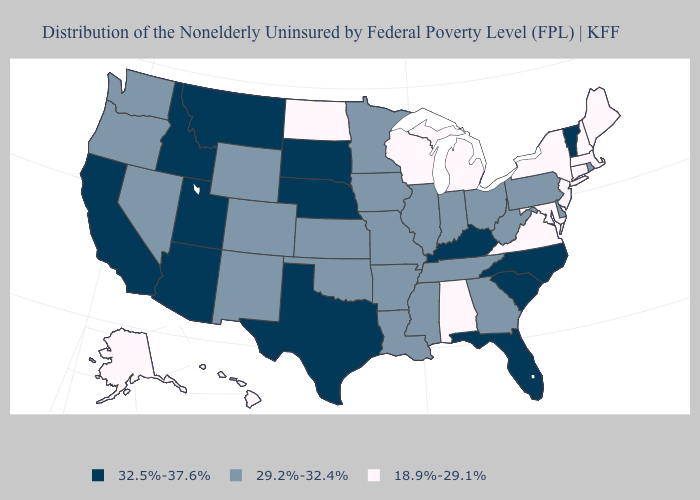Name the states that have a value in the range 32.5%-37.6%?
Be succinct. Arizona, California, Florida, Idaho, Kentucky, Montana, Nebraska, North Carolina, South Carolina, South Dakota, Texas, Utah, Vermont. Name the states that have a value in the range 32.5%-37.6%?
Short answer required. Arizona, California, Florida, Idaho, Kentucky, Montana, Nebraska, North Carolina, South Carolina, South Dakota, Texas, Utah, Vermont. Name the states that have a value in the range 29.2%-32.4%?
Short answer required. Arkansas, Colorado, Delaware, Georgia, Illinois, Indiana, Iowa, Kansas, Louisiana, Minnesota, Mississippi, Missouri, Nevada, New Mexico, Ohio, Oklahoma, Oregon, Pennsylvania, Rhode Island, Tennessee, Washington, West Virginia, Wyoming. Name the states that have a value in the range 18.9%-29.1%?
Concise answer only. Alabama, Alaska, Connecticut, Hawaii, Maine, Maryland, Massachusetts, Michigan, New Hampshire, New Jersey, New York, North Dakota, Virginia, Wisconsin. What is the value of Delaware?
Answer briefly. 29.2%-32.4%. Among the states that border Iowa , does Illinois have the highest value?
Give a very brief answer. No. Does the first symbol in the legend represent the smallest category?
Be succinct. No. Name the states that have a value in the range 32.5%-37.6%?
Write a very short answer. Arizona, California, Florida, Idaho, Kentucky, Montana, Nebraska, North Carolina, South Carolina, South Dakota, Texas, Utah, Vermont. What is the highest value in the USA?
Answer briefly. 32.5%-37.6%. What is the value of Connecticut?
Write a very short answer. 18.9%-29.1%. What is the value of North Dakota?
Write a very short answer. 18.9%-29.1%. Does Nevada have the highest value in the USA?
Quick response, please. No. Does the map have missing data?
Keep it brief. No. What is the lowest value in the USA?
Short answer required. 18.9%-29.1%. What is the highest value in the USA?
Write a very short answer. 32.5%-37.6%. 